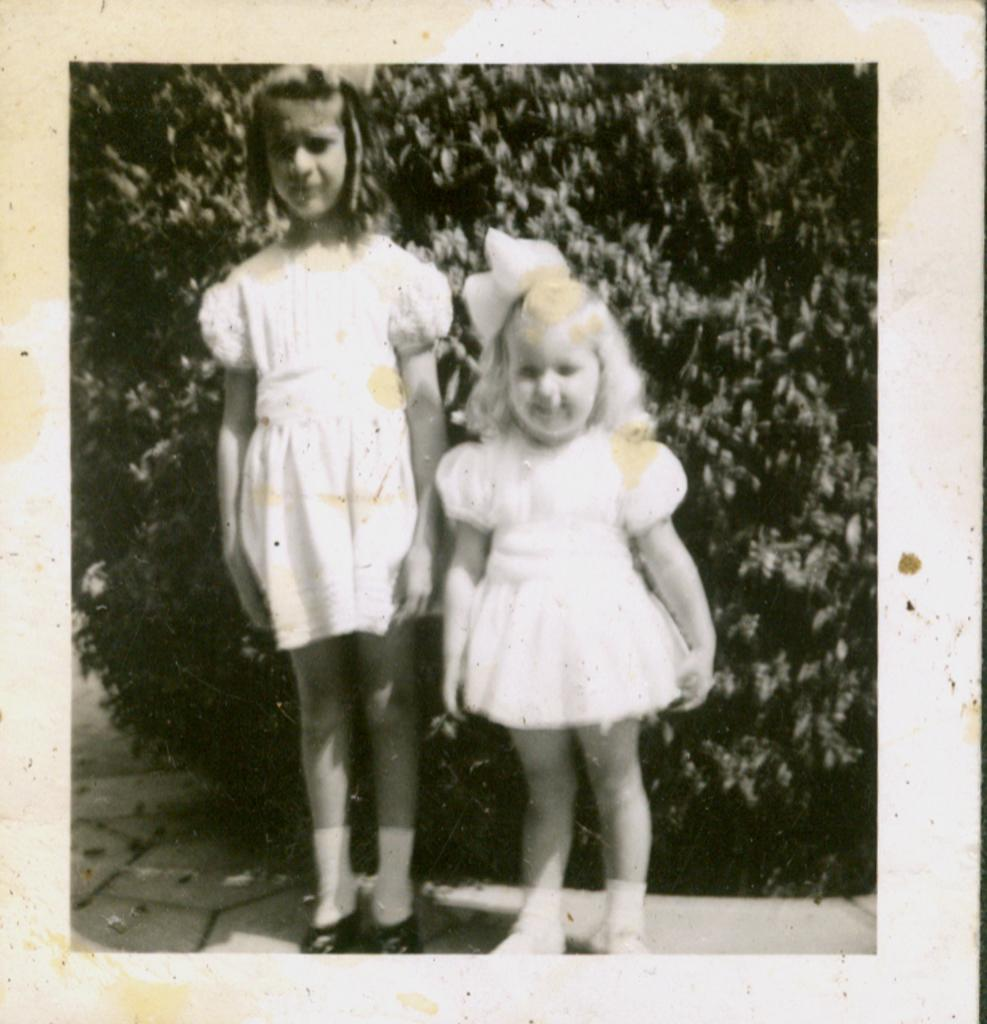What object is present in the image that typically holds a photograph? There is a photo frame in the image. What can be seen inside the photo frame? The photo frame contains a picture of two girls. What type of natural scenery is visible in the background of the image? There are trees visible in the background of the image. How many men are present in the image? There are no men present in the image; it features a photo frame with a picture of two girls. What is the size of the quince in the image? There is no quince present in the image. 